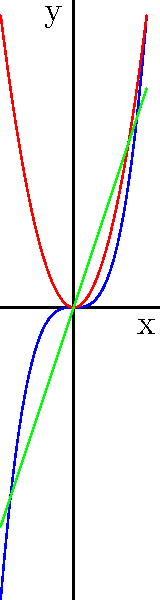As the manager of a tech publication, you're reviewing an article comparing the growth rates of different technologies. The author has used polynomial functions to model the growth, represented by the graph above. Which function grows the fastest as x approaches positive infinity, and how does this relate to reporting on technological advancements? To determine which function grows the fastest as x approaches positive infinity, we need to analyze the behavior of each function for large positive x values:

1. Blue curve: $f_1(x) = x^3$ (cubic function)
2. Red curve: $f_2(x) = 2x^2$ (quadratic function)
3. Green curve: $f_3(x) = 3x$ (linear function)

Step 1: Compare the degrees of the polynomials
- $f_1(x)$ has degree 3
- $f_2(x)$ has degree 2
- $f_3(x)$ has degree 1

The function with the highest degree will always grow the fastest as x approaches infinity.

Step 2: Verify graphically
As we can see from the graph, the blue curve ($x^3$) eventually surpasses both the red ($2x^2$) and green ($3x$) curves as x increases.

Step 3: Relate to technological advancements
In the context of reporting on technological advancements, this analysis demonstrates the importance of considering long-term trends. While some technologies may show faster growth initially (like the linear or quadratic functions), others may have the potential for exponential or cubic growth, ultimately outpacing the others in the long run.

This emphasizes the need for diverse perspectives in reporting, as different experts may focus on different time scales or growth patterns when analyzing technological trends.
Answer: $f_1(x) = x^3$ grows the fastest; highlights importance of long-term trend analysis in tech reporting. 